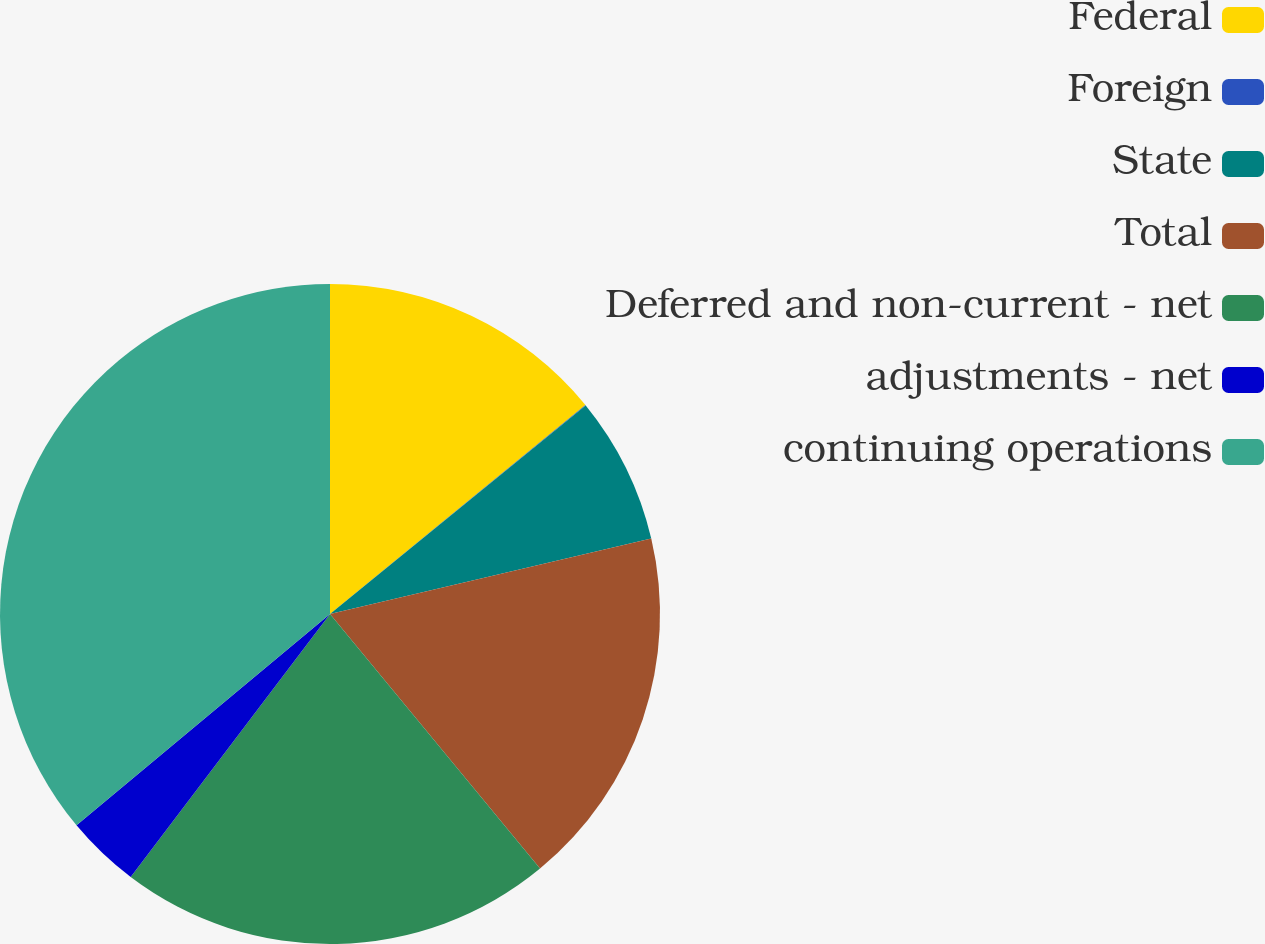<chart> <loc_0><loc_0><loc_500><loc_500><pie_chart><fcel>Federal<fcel>Foreign<fcel>State<fcel>Total<fcel>Deferred and non-current - net<fcel>adjustments - net<fcel>continuing operations<nl><fcel>14.09%<fcel>0.02%<fcel>7.22%<fcel>17.69%<fcel>21.3%<fcel>3.62%<fcel>36.06%<nl></chart> 